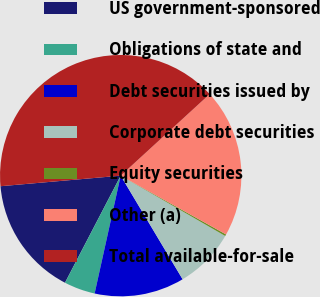<chart> <loc_0><loc_0><loc_500><loc_500><pie_chart><fcel>US government-sponsored<fcel>Obligations of state and<fcel>Debt securities issued by<fcel>Corporate debt securities<fcel>Equity securities<fcel>Other (a)<fcel>Total available-for-sale<nl><fcel>15.97%<fcel>4.17%<fcel>12.04%<fcel>8.1%<fcel>0.23%<fcel>19.91%<fcel>39.59%<nl></chart> 